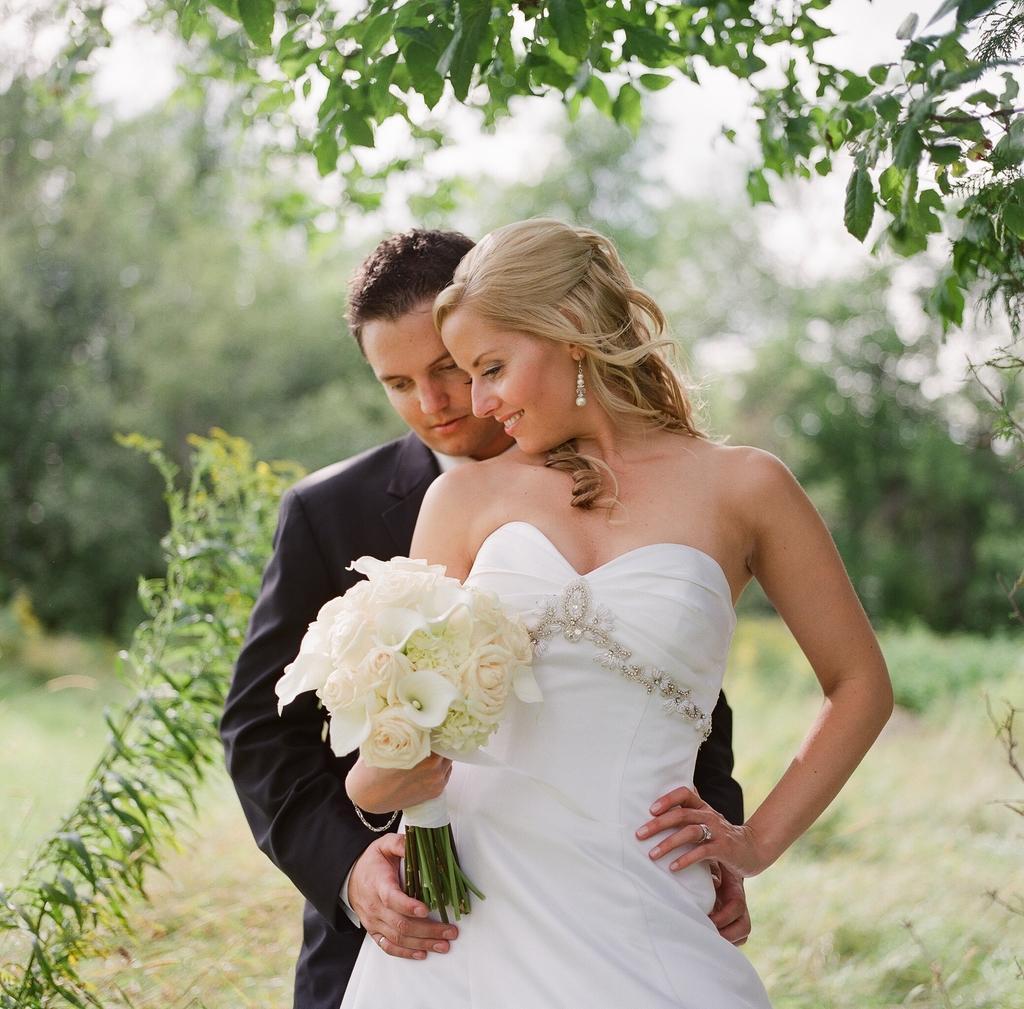In one or two sentences, can you explain what this image depicts? In this image, we can see a man and a lady and the lady is holding flowers in her hand. In the background, there are trees and at the bottom, there is ground. 